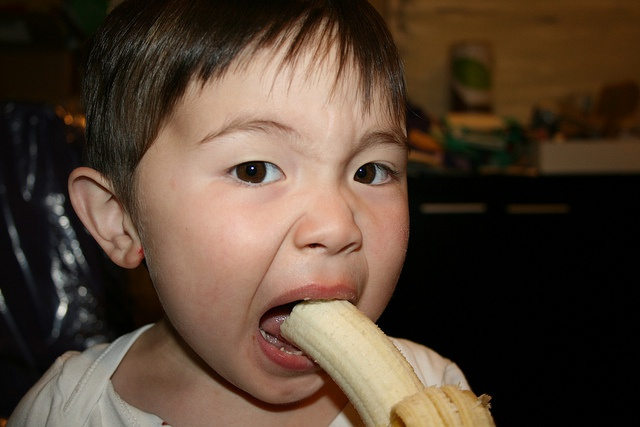Describe the objects in this image and their specific colors. I can see people in black, tan, and gray tones and banana in black and tan tones in this image. 